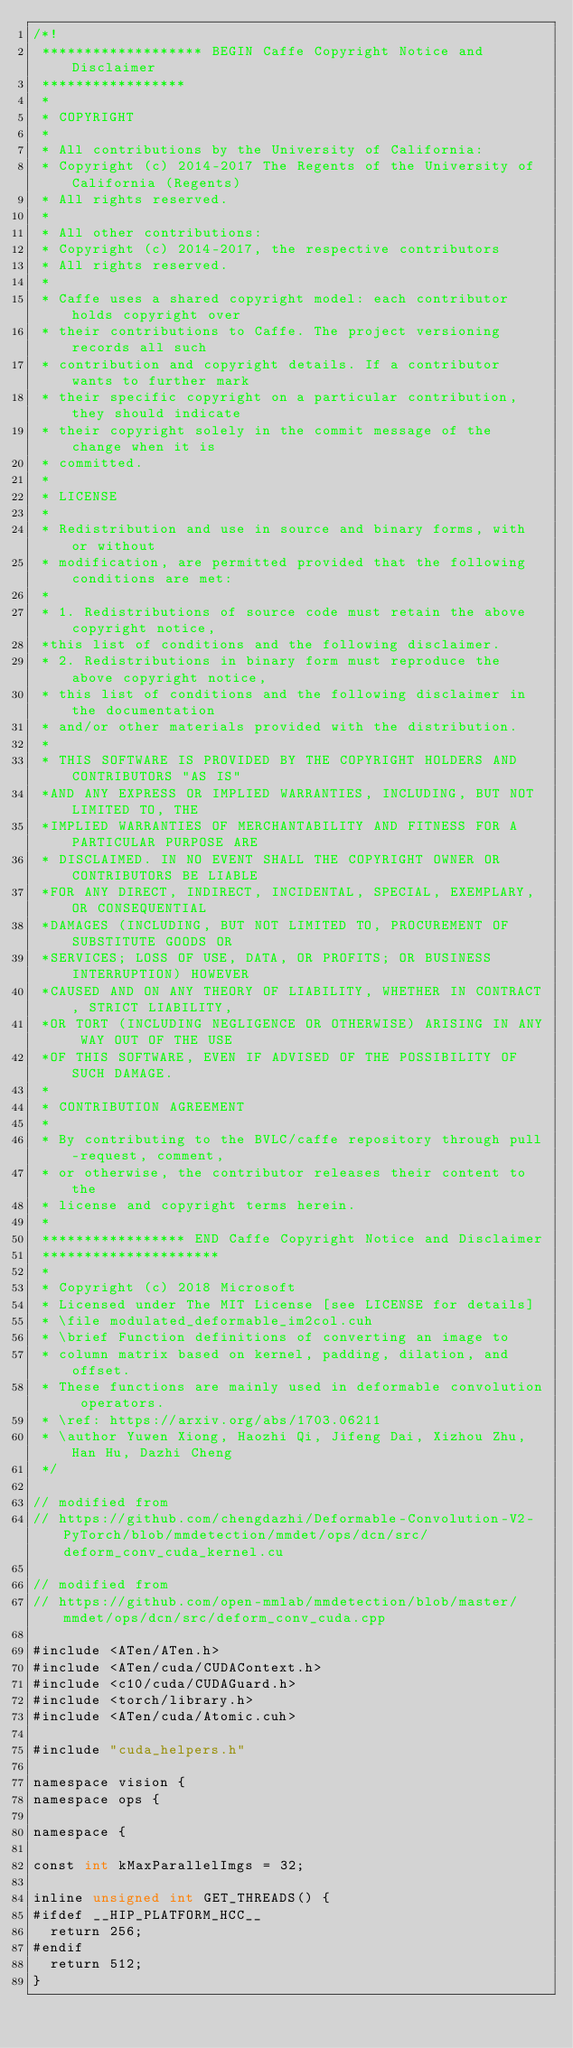<code> <loc_0><loc_0><loc_500><loc_500><_Cuda_>/*!
 ******************* BEGIN Caffe Copyright Notice and Disclaimer
 *****************
 *
 * COPYRIGHT
 *
 * All contributions by the University of California:
 * Copyright (c) 2014-2017 The Regents of the University of California (Regents)
 * All rights reserved.
 *
 * All other contributions:
 * Copyright (c) 2014-2017, the respective contributors
 * All rights reserved.
 *
 * Caffe uses a shared copyright model: each contributor holds copyright over
 * their contributions to Caffe. The project versioning records all such
 * contribution and copyright details. If a contributor wants to further mark
 * their specific copyright on a particular contribution, they should indicate
 * their copyright solely in the commit message of the change when it is
 * committed.
 *
 * LICENSE
 *
 * Redistribution and use in source and binary forms, with or without
 * modification, are permitted provided that the following conditions are met:
 *
 * 1. Redistributions of source code must retain the above copyright notice,
 *this list of conditions and the following disclaimer.
 * 2. Redistributions in binary form must reproduce the above copyright notice,
 * this list of conditions and the following disclaimer in the documentation
 * and/or other materials provided with the distribution.
 *
 * THIS SOFTWARE IS PROVIDED BY THE COPYRIGHT HOLDERS AND CONTRIBUTORS "AS IS"
 *AND ANY EXPRESS OR IMPLIED WARRANTIES, INCLUDING, BUT NOT LIMITED TO, THE
 *IMPLIED WARRANTIES OF MERCHANTABILITY AND FITNESS FOR A PARTICULAR PURPOSE ARE
 * DISCLAIMED. IN NO EVENT SHALL THE COPYRIGHT OWNER OR CONTRIBUTORS BE LIABLE
 *FOR ANY DIRECT, INDIRECT, INCIDENTAL, SPECIAL, EXEMPLARY, OR CONSEQUENTIAL
 *DAMAGES (INCLUDING, BUT NOT LIMITED TO, PROCUREMENT OF SUBSTITUTE GOODS OR
 *SERVICES; LOSS OF USE, DATA, OR PROFITS; OR BUSINESS INTERRUPTION) HOWEVER
 *CAUSED AND ON ANY THEORY OF LIABILITY, WHETHER IN CONTRACT, STRICT LIABILITY,
 *OR TORT (INCLUDING NEGLIGENCE OR OTHERWISE) ARISING IN ANY WAY OUT OF THE USE
 *OF THIS SOFTWARE, EVEN IF ADVISED OF THE POSSIBILITY OF SUCH DAMAGE.
 *
 * CONTRIBUTION AGREEMENT
 *
 * By contributing to the BVLC/caffe repository through pull-request, comment,
 * or otherwise, the contributor releases their content to the
 * license and copyright terms herein.
 *
 ***************** END Caffe Copyright Notice and Disclaimer
 *********************
 *
 * Copyright (c) 2018 Microsoft
 * Licensed under The MIT License [see LICENSE for details]
 * \file modulated_deformable_im2col.cuh
 * \brief Function definitions of converting an image to
 * column matrix based on kernel, padding, dilation, and offset.
 * These functions are mainly used in deformable convolution operators.
 * \ref: https://arxiv.org/abs/1703.06211
 * \author Yuwen Xiong, Haozhi Qi, Jifeng Dai, Xizhou Zhu, Han Hu, Dazhi Cheng
 */

// modified from
// https://github.com/chengdazhi/Deformable-Convolution-V2-PyTorch/blob/mmdetection/mmdet/ops/dcn/src/deform_conv_cuda_kernel.cu

// modified from
// https://github.com/open-mmlab/mmdetection/blob/master/mmdet/ops/dcn/src/deform_conv_cuda.cpp

#include <ATen/ATen.h>
#include <ATen/cuda/CUDAContext.h>
#include <c10/cuda/CUDAGuard.h>
#include <torch/library.h>
#include <ATen/cuda/Atomic.cuh>

#include "cuda_helpers.h"

namespace vision {
namespace ops {

namespace {

const int kMaxParallelImgs = 32;

inline unsigned int GET_THREADS() {
#ifdef __HIP_PLATFORM_HCC__
  return 256;
#endif
  return 512;
}
</code> 